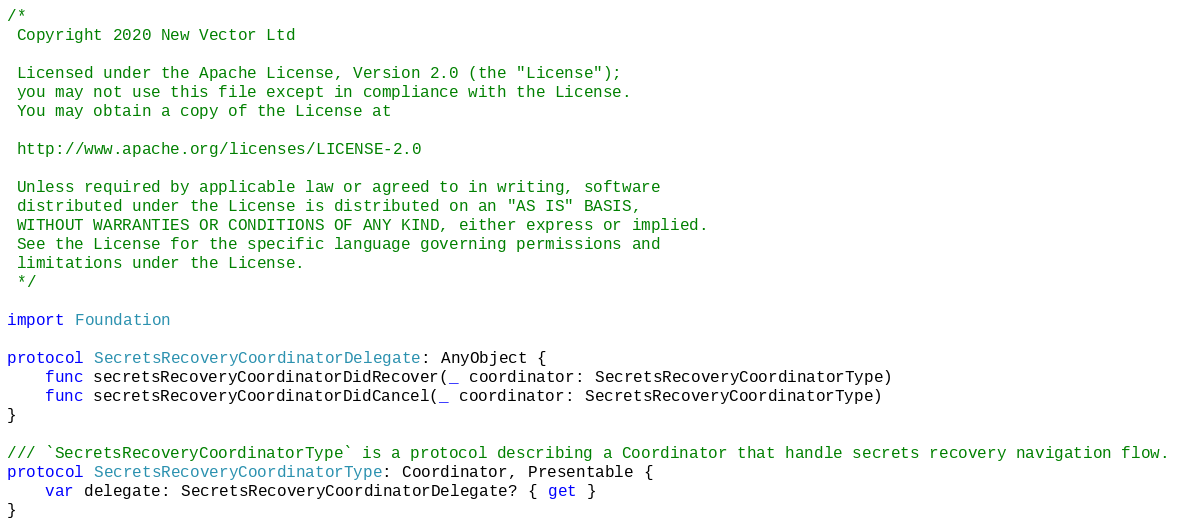<code> <loc_0><loc_0><loc_500><loc_500><_Swift_>/*
 Copyright 2020 New Vector Ltd
 
 Licensed under the Apache License, Version 2.0 (the "License");
 you may not use this file except in compliance with the License.
 You may obtain a copy of the License at
 
 http://www.apache.org/licenses/LICENSE-2.0
 
 Unless required by applicable law or agreed to in writing, software
 distributed under the License is distributed on an "AS IS" BASIS,
 WITHOUT WARRANTIES OR CONDITIONS OF ANY KIND, either express or implied.
 See the License for the specific language governing permissions and
 limitations under the License.
 */

import Foundation

protocol SecretsRecoveryCoordinatorDelegate: AnyObject {
    func secretsRecoveryCoordinatorDidRecover(_ coordinator: SecretsRecoveryCoordinatorType)
    func secretsRecoveryCoordinatorDidCancel(_ coordinator: SecretsRecoveryCoordinatorType)
}

/// `SecretsRecoveryCoordinatorType` is a protocol describing a Coordinator that handle secrets recovery navigation flow.
protocol SecretsRecoveryCoordinatorType: Coordinator, Presentable {
    var delegate: SecretsRecoveryCoordinatorDelegate? { get }
}
</code> 